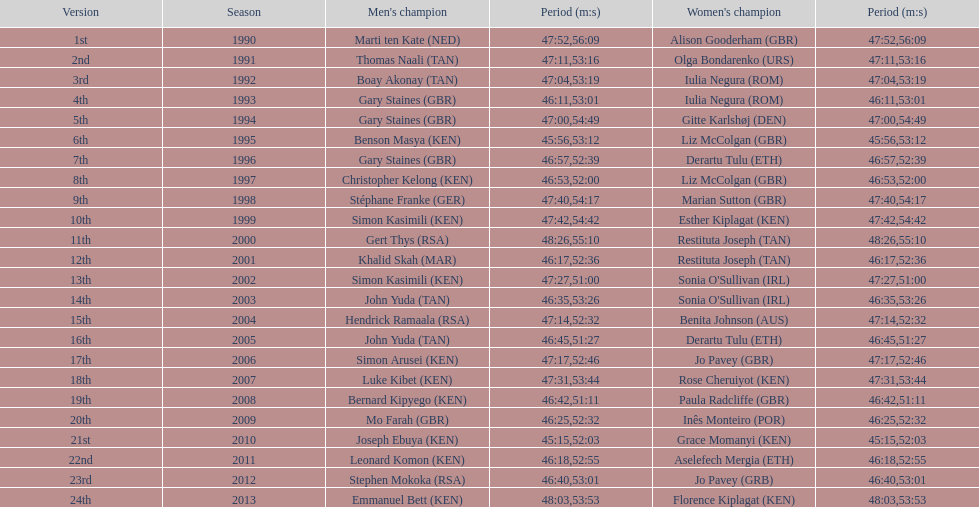Who has the fastest recorded finish for the men's bupa great south run, between 1990 and 2013? Joseph Ebuya (KEN). 